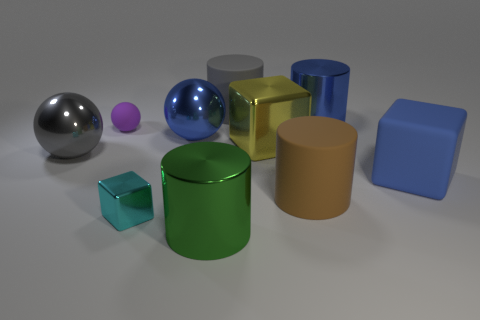The big metal thing that is both on the right side of the gray matte cylinder and in front of the blue cylinder has what shape?
Provide a succinct answer. Cube. There is a large object that is left of the big green metallic cylinder and to the right of the tiny cyan thing; what material is it?
Keep it short and to the point. Metal. What shape is the blue thing that is the same material as the purple sphere?
Your response must be concise. Cube. Are there any other things that are the same color as the tiny metallic thing?
Keep it short and to the point. No. Are there more tiny matte spheres that are in front of the big yellow block than tiny cyan cylinders?
Provide a short and direct response. No. What material is the cyan object?
Make the answer very short. Metal. How many cyan matte balls are the same size as the gray matte thing?
Give a very brief answer. 0. Are there an equal number of gray shiny things behind the green cylinder and big cylinders in front of the cyan shiny thing?
Provide a short and direct response. Yes. Does the cyan thing have the same material as the big brown cylinder?
Your response must be concise. No. Is there a tiny purple rubber object on the right side of the big shiny cylinder that is in front of the large blue matte thing?
Ensure brevity in your answer.  No. 